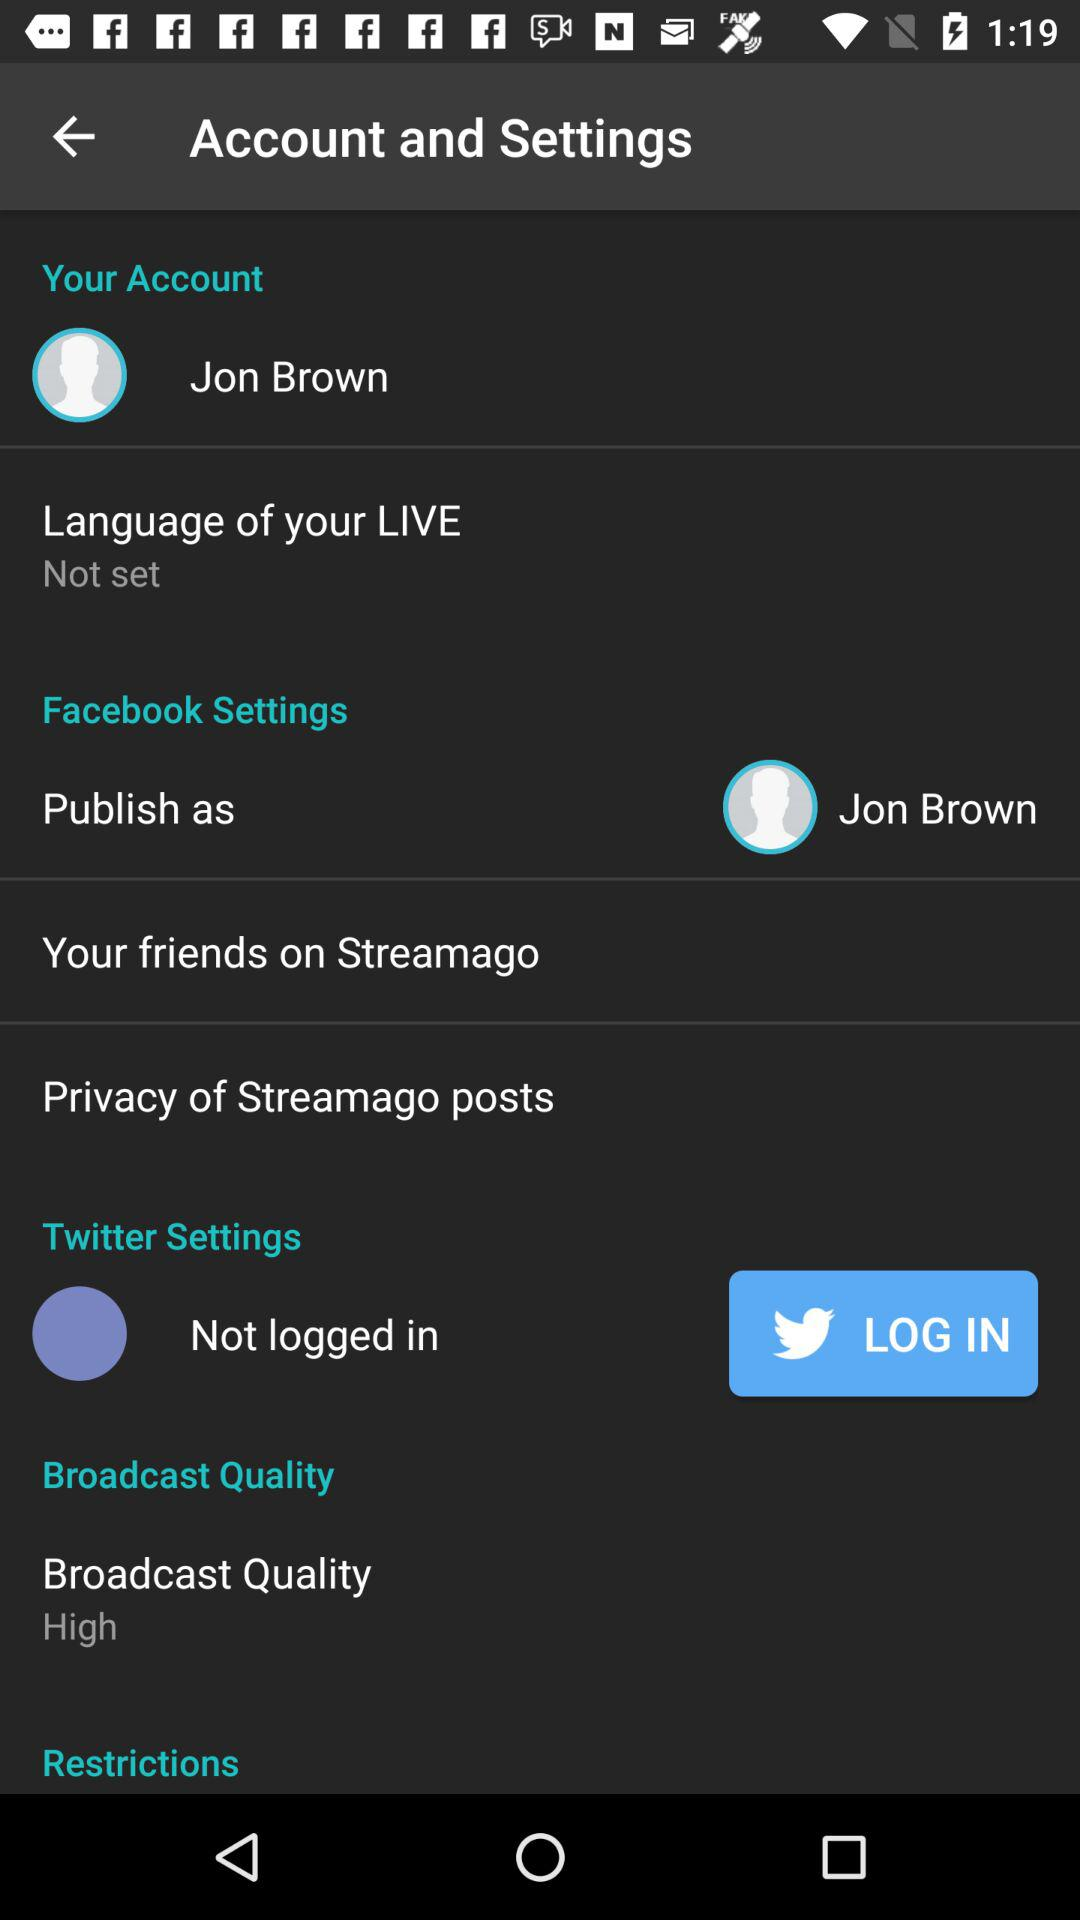What is the setting for the broadcast quality? The setting for the broadcast quality is "High". 